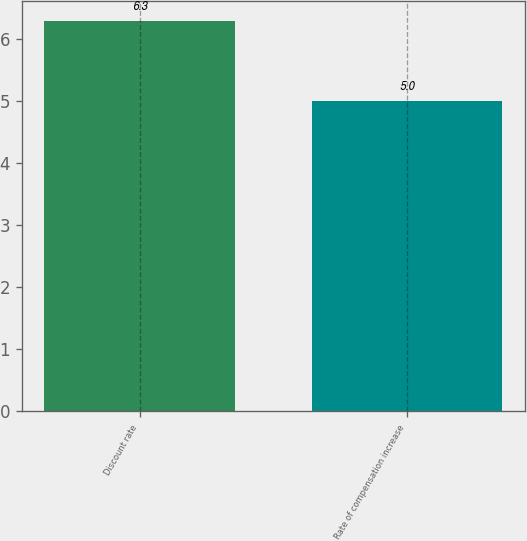Convert chart to OTSL. <chart><loc_0><loc_0><loc_500><loc_500><bar_chart><fcel>Discount rate<fcel>Rate of compensation increase<nl><fcel>6.3<fcel>5<nl></chart> 